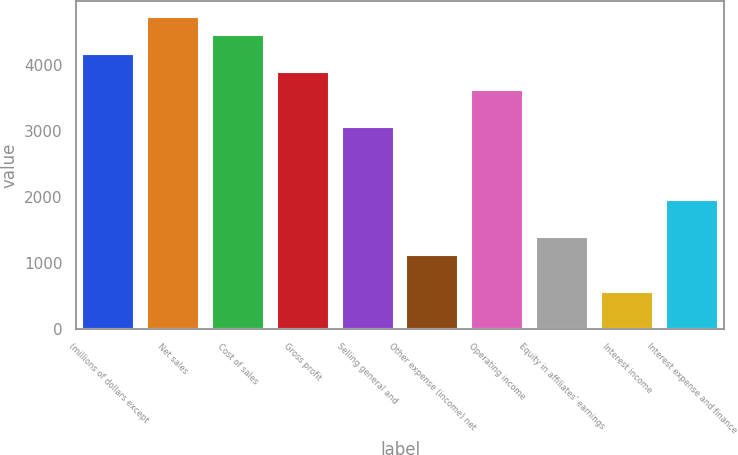<chart> <loc_0><loc_0><loc_500><loc_500><bar_chart><fcel>(millions of dollars except<fcel>Net sales<fcel>Cost of sales<fcel>Gross profit<fcel>Selling general and<fcel>Other expense (income) net<fcel>Operating income<fcel>Equity in affiliates' earnings<fcel>Interest income<fcel>Interest expense and finance<nl><fcel>4175.87<fcel>4732.51<fcel>4454.19<fcel>3897.55<fcel>3062.59<fcel>1114.35<fcel>3619.23<fcel>1392.67<fcel>557.71<fcel>1949.31<nl></chart> 